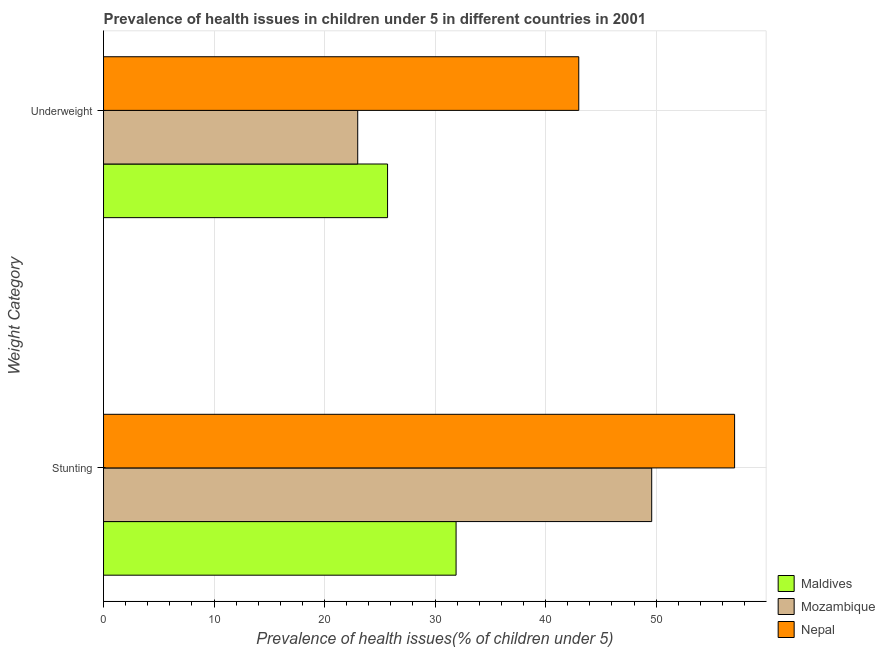How many different coloured bars are there?
Your answer should be compact. 3. What is the label of the 2nd group of bars from the top?
Give a very brief answer. Stunting. What is the percentage of stunted children in Maldives?
Your answer should be very brief. 31.9. Across all countries, what is the minimum percentage of stunted children?
Make the answer very short. 31.9. In which country was the percentage of stunted children maximum?
Offer a terse response. Nepal. In which country was the percentage of stunted children minimum?
Make the answer very short. Maldives. What is the total percentage of underweight children in the graph?
Keep it short and to the point. 91.7. What is the difference between the percentage of stunted children in Maldives and that in Mozambique?
Provide a short and direct response. -17.7. What is the difference between the percentage of stunted children in Nepal and the percentage of underweight children in Maldives?
Keep it short and to the point. 31.4. What is the average percentage of stunted children per country?
Your answer should be compact. 46.2. What is the difference between the percentage of underweight children and percentage of stunted children in Nepal?
Provide a succinct answer. -14.1. In how many countries, is the percentage of underweight children greater than 42 %?
Offer a very short reply. 1. What is the ratio of the percentage of underweight children in Mozambique to that in Nepal?
Your answer should be very brief. 0.53. What does the 1st bar from the top in Underweight represents?
Your answer should be compact. Nepal. What does the 2nd bar from the bottom in Stunting represents?
Ensure brevity in your answer.  Mozambique. How many bars are there?
Make the answer very short. 6. How many countries are there in the graph?
Offer a terse response. 3. What is the difference between two consecutive major ticks on the X-axis?
Your response must be concise. 10. Does the graph contain grids?
Give a very brief answer. Yes. What is the title of the graph?
Your response must be concise. Prevalence of health issues in children under 5 in different countries in 2001. Does "Latin America(developing only)" appear as one of the legend labels in the graph?
Your response must be concise. No. What is the label or title of the X-axis?
Offer a very short reply. Prevalence of health issues(% of children under 5). What is the label or title of the Y-axis?
Keep it short and to the point. Weight Category. What is the Prevalence of health issues(% of children under 5) of Maldives in Stunting?
Make the answer very short. 31.9. What is the Prevalence of health issues(% of children under 5) of Mozambique in Stunting?
Your answer should be compact. 49.6. What is the Prevalence of health issues(% of children under 5) of Nepal in Stunting?
Offer a very short reply. 57.1. What is the Prevalence of health issues(% of children under 5) in Maldives in Underweight?
Offer a very short reply. 25.7. Across all Weight Category, what is the maximum Prevalence of health issues(% of children under 5) of Maldives?
Make the answer very short. 31.9. Across all Weight Category, what is the maximum Prevalence of health issues(% of children under 5) in Mozambique?
Offer a very short reply. 49.6. Across all Weight Category, what is the maximum Prevalence of health issues(% of children under 5) in Nepal?
Your answer should be very brief. 57.1. Across all Weight Category, what is the minimum Prevalence of health issues(% of children under 5) of Maldives?
Your answer should be very brief. 25.7. What is the total Prevalence of health issues(% of children under 5) in Maldives in the graph?
Your answer should be very brief. 57.6. What is the total Prevalence of health issues(% of children under 5) in Mozambique in the graph?
Offer a very short reply. 72.6. What is the total Prevalence of health issues(% of children under 5) in Nepal in the graph?
Your answer should be compact. 100.1. What is the difference between the Prevalence of health issues(% of children under 5) in Maldives in Stunting and that in Underweight?
Your response must be concise. 6.2. What is the difference between the Prevalence of health issues(% of children under 5) in Mozambique in Stunting and that in Underweight?
Give a very brief answer. 26.6. What is the difference between the Prevalence of health issues(% of children under 5) of Mozambique in Stunting and the Prevalence of health issues(% of children under 5) of Nepal in Underweight?
Provide a succinct answer. 6.6. What is the average Prevalence of health issues(% of children under 5) in Maldives per Weight Category?
Give a very brief answer. 28.8. What is the average Prevalence of health issues(% of children under 5) of Mozambique per Weight Category?
Ensure brevity in your answer.  36.3. What is the average Prevalence of health issues(% of children under 5) of Nepal per Weight Category?
Your answer should be compact. 50.05. What is the difference between the Prevalence of health issues(% of children under 5) of Maldives and Prevalence of health issues(% of children under 5) of Mozambique in Stunting?
Your response must be concise. -17.7. What is the difference between the Prevalence of health issues(% of children under 5) of Maldives and Prevalence of health issues(% of children under 5) of Nepal in Stunting?
Offer a very short reply. -25.2. What is the difference between the Prevalence of health issues(% of children under 5) of Mozambique and Prevalence of health issues(% of children under 5) of Nepal in Stunting?
Your answer should be compact. -7.5. What is the difference between the Prevalence of health issues(% of children under 5) in Maldives and Prevalence of health issues(% of children under 5) in Mozambique in Underweight?
Provide a succinct answer. 2.7. What is the difference between the Prevalence of health issues(% of children under 5) in Maldives and Prevalence of health issues(% of children under 5) in Nepal in Underweight?
Keep it short and to the point. -17.3. What is the difference between the Prevalence of health issues(% of children under 5) in Mozambique and Prevalence of health issues(% of children under 5) in Nepal in Underweight?
Give a very brief answer. -20. What is the ratio of the Prevalence of health issues(% of children under 5) of Maldives in Stunting to that in Underweight?
Your answer should be compact. 1.24. What is the ratio of the Prevalence of health issues(% of children under 5) of Mozambique in Stunting to that in Underweight?
Give a very brief answer. 2.16. What is the ratio of the Prevalence of health issues(% of children under 5) of Nepal in Stunting to that in Underweight?
Make the answer very short. 1.33. What is the difference between the highest and the second highest Prevalence of health issues(% of children under 5) of Mozambique?
Offer a very short reply. 26.6. What is the difference between the highest and the lowest Prevalence of health issues(% of children under 5) of Maldives?
Your response must be concise. 6.2. What is the difference between the highest and the lowest Prevalence of health issues(% of children under 5) of Mozambique?
Offer a very short reply. 26.6. What is the difference between the highest and the lowest Prevalence of health issues(% of children under 5) in Nepal?
Your answer should be very brief. 14.1. 